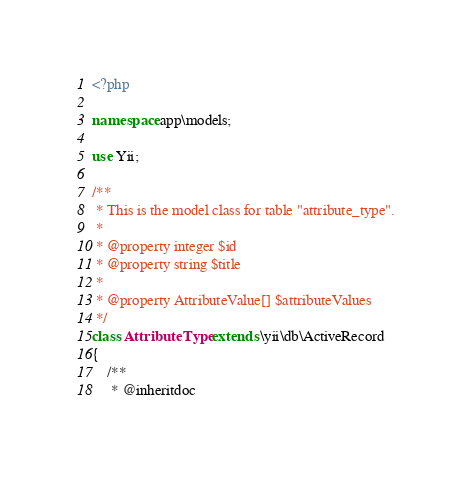Convert code to text. <code><loc_0><loc_0><loc_500><loc_500><_PHP_><?php

namespace app\models;

use Yii;

/**
 * This is the model class for table "attribute_type".
 *
 * @property integer $id
 * @property string $title
 *
 * @property AttributeValue[] $attributeValues
 */
class AttributeType extends \yii\db\ActiveRecord
{
    /**
     * @inheritdoc</code> 